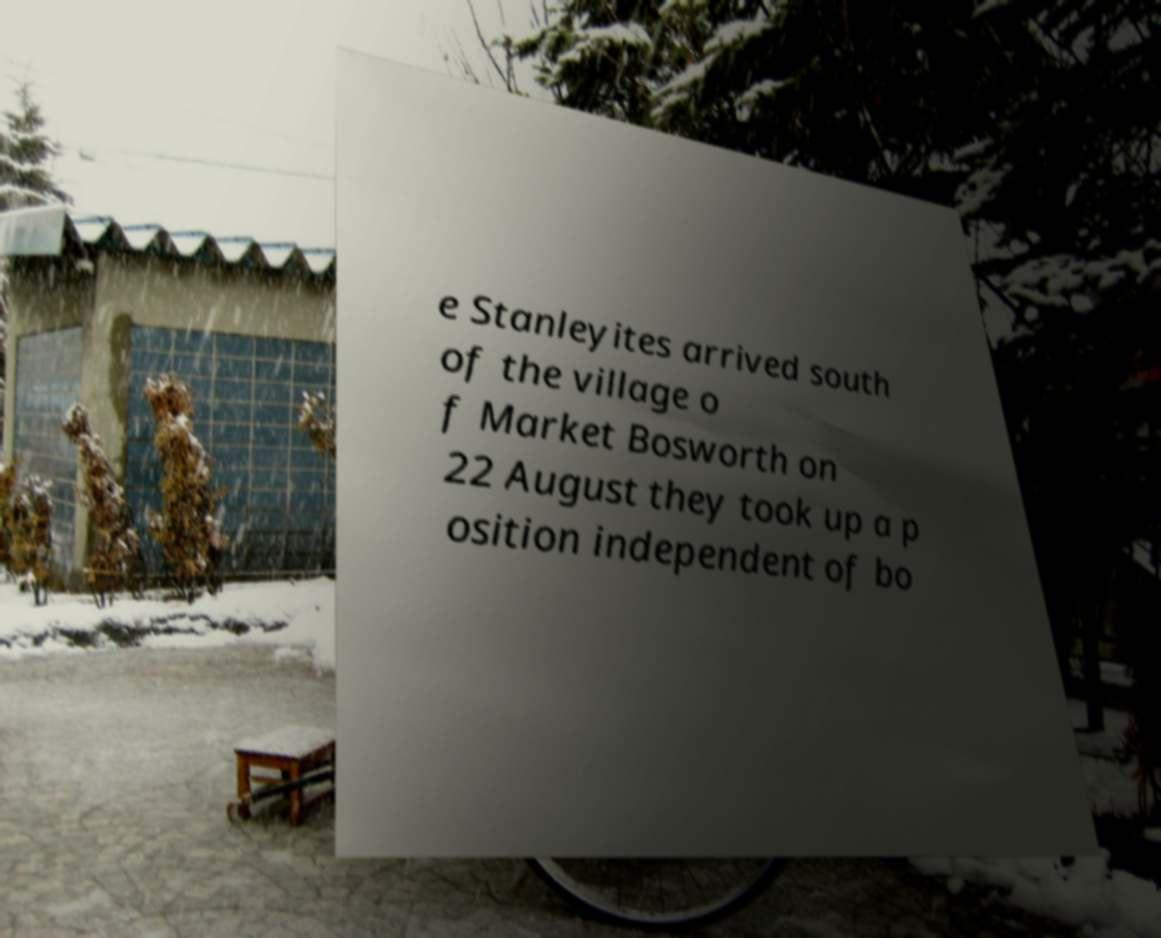Could you assist in decoding the text presented in this image and type it out clearly? e Stanleyites arrived south of the village o f Market Bosworth on 22 August they took up a p osition independent of bo 